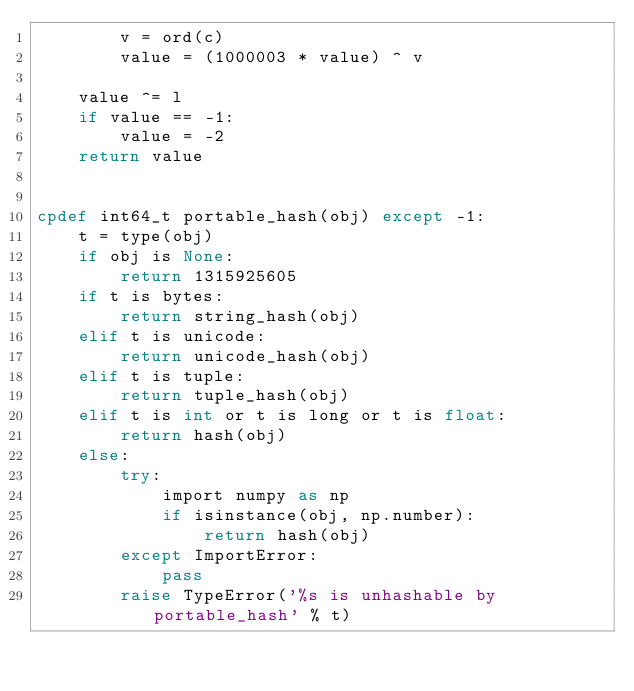<code> <loc_0><loc_0><loc_500><loc_500><_Cython_>        v = ord(c)
        value = (1000003 * value) ^ v

    value ^= l
    if value == -1:
        value = -2
    return value


cpdef int64_t portable_hash(obj) except -1:
    t = type(obj)
    if obj is None:
        return 1315925605
    if t is bytes:
        return string_hash(obj)
    elif t is unicode:
        return unicode_hash(obj)
    elif t is tuple:
        return tuple_hash(obj)
    elif t is int or t is long or t is float:
        return hash(obj)
    else:
        try:
            import numpy as np
            if isinstance(obj, np.number):
                return hash(obj)
        except ImportError:
            pass
        raise TypeError('%s is unhashable by portable_hash' % t)
</code> 